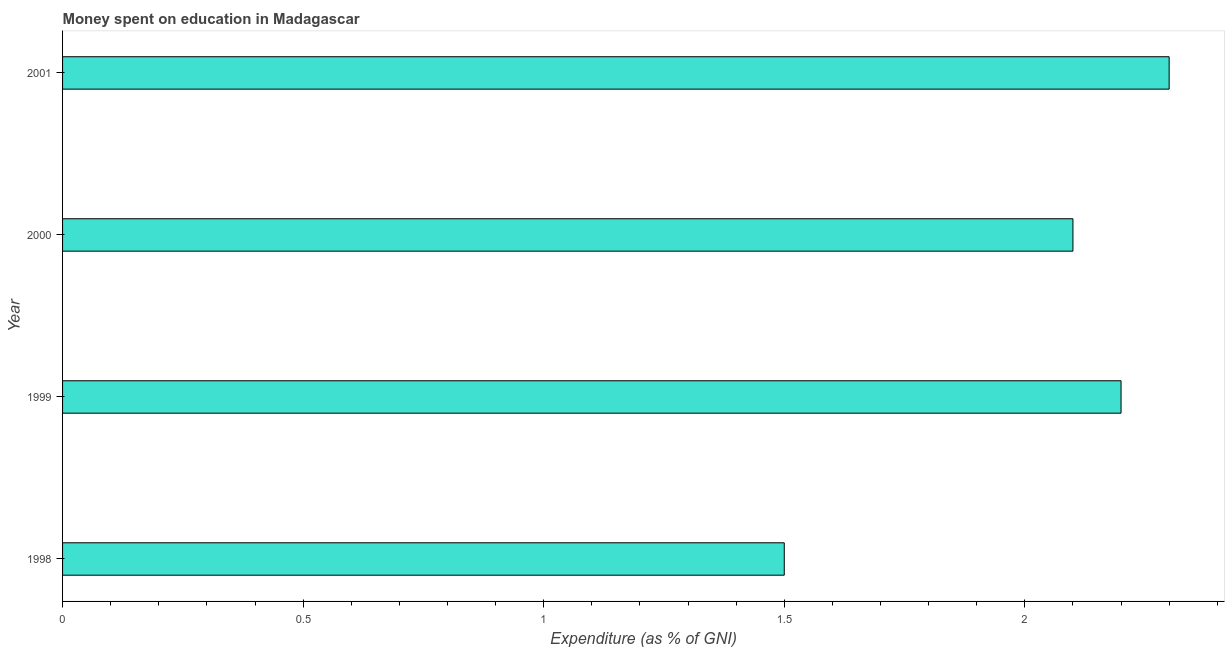Does the graph contain grids?
Provide a short and direct response. No. What is the title of the graph?
Your answer should be very brief. Money spent on education in Madagascar. What is the label or title of the X-axis?
Make the answer very short. Expenditure (as % of GNI). What is the expenditure on education in 2000?
Make the answer very short. 2.1. In which year was the expenditure on education maximum?
Your response must be concise. 2001. What is the sum of the expenditure on education?
Keep it short and to the point. 8.1. What is the average expenditure on education per year?
Your answer should be compact. 2.02. What is the median expenditure on education?
Provide a succinct answer. 2.15. What is the ratio of the expenditure on education in 1998 to that in 2001?
Offer a terse response. 0.65. Is the expenditure on education in 1998 less than that in 2001?
Provide a short and direct response. Yes. Is the difference between the expenditure on education in 1998 and 2001 greater than the difference between any two years?
Your answer should be compact. Yes. What is the difference between the highest and the lowest expenditure on education?
Give a very brief answer. 0.8. In how many years, is the expenditure on education greater than the average expenditure on education taken over all years?
Your response must be concise. 3. What is the Expenditure (as % of GNI) of 1999?
Your answer should be compact. 2.2. What is the Expenditure (as % of GNI) of 2000?
Provide a succinct answer. 2.1. What is the difference between the Expenditure (as % of GNI) in 2000 and 2001?
Offer a terse response. -0.2. What is the ratio of the Expenditure (as % of GNI) in 1998 to that in 1999?
Make the answer very short. 0.68. What is the ratio of the Expenditure (as % of GNI) in 1998 to that in 2000?
Keep it short and to the point. 0.71. What is the ratio of the Expenditure (as % of GNI) in 1998 to that in 2001?
Ensure brevity in your answer.  0.65. What is the ratio of the Expenditure (as % of GNI) in 1999 to that in 2000?
Provide a succinct answer. 1.05. What is the ratio of the Expenditure (as % of GNI) in 1999 to that in 2001?
Offer a terse response. 0.96. 